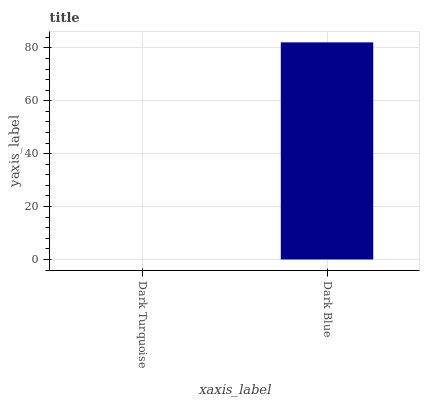Is Dark Blue the minimum?
Answer yes or no. No. Is Dark Blue greater than Dark Turquoise?
Answer yes or no. Yes. Is Dark Turquoise less than Dark Blue?
Answer yes or no. Yes. Is Dark Turquoise greater than Dark Blue?
Answer yes or no. No. Is Dark Blue less than Dark Turquoise?
Answer yes or no. No. Is Dark Blue the high median?
Answer yes or no. Yes. Is Dark Turquoise the low median?
Answer yes or no. Yes. Is Dark Turquoise the high median?
Answer yes or no. No. Is Dark Blue the low median?
Answer yes or no. No. 